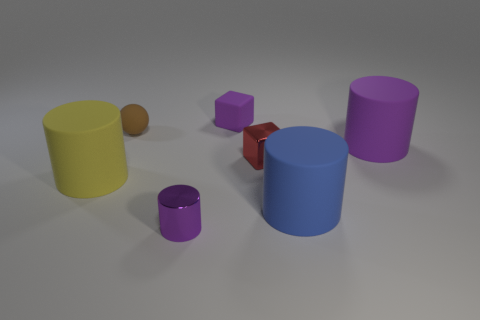Are there the same number of tiny brown matte objects that are to the right of the tiny metallic block and purple matte things that are in front of the brown rubber ball?
Your response must be concise. No. What color is the shiny cylinder that is the same size as the brown object?
Make the answer very short. Purple. Is there a big rubber cylinder of the same color as the matte cube?
Offer a terse response. Yes. How many things are tiny objects in front of the ball or blocks?
Offer a very short reply. 3. What number of other things are the same size as the sphere?
Your response must be concise. 3. There is a big cylinder that is on the left side of the purple object behind the purple cylinder behind the large yellow cylinder; what is it made of?
Make the answer very short. Rubber. What number of cylinders are either purple matte things or large purple things?
Provide a succinct answer. 1. Is there anything else that is the same shape as the brown matte thing?
Offer a terse response. No. Is the number of purple blocks in front of the small purple rubber object greater than the number of tiny brown rubber balls to the right of the big blue thing?
Give a very brief answer. No. There is a rubber object that is right of the large blue thing; what number of purple things are on the left side of it?
Provide a short and direct response. 2. 